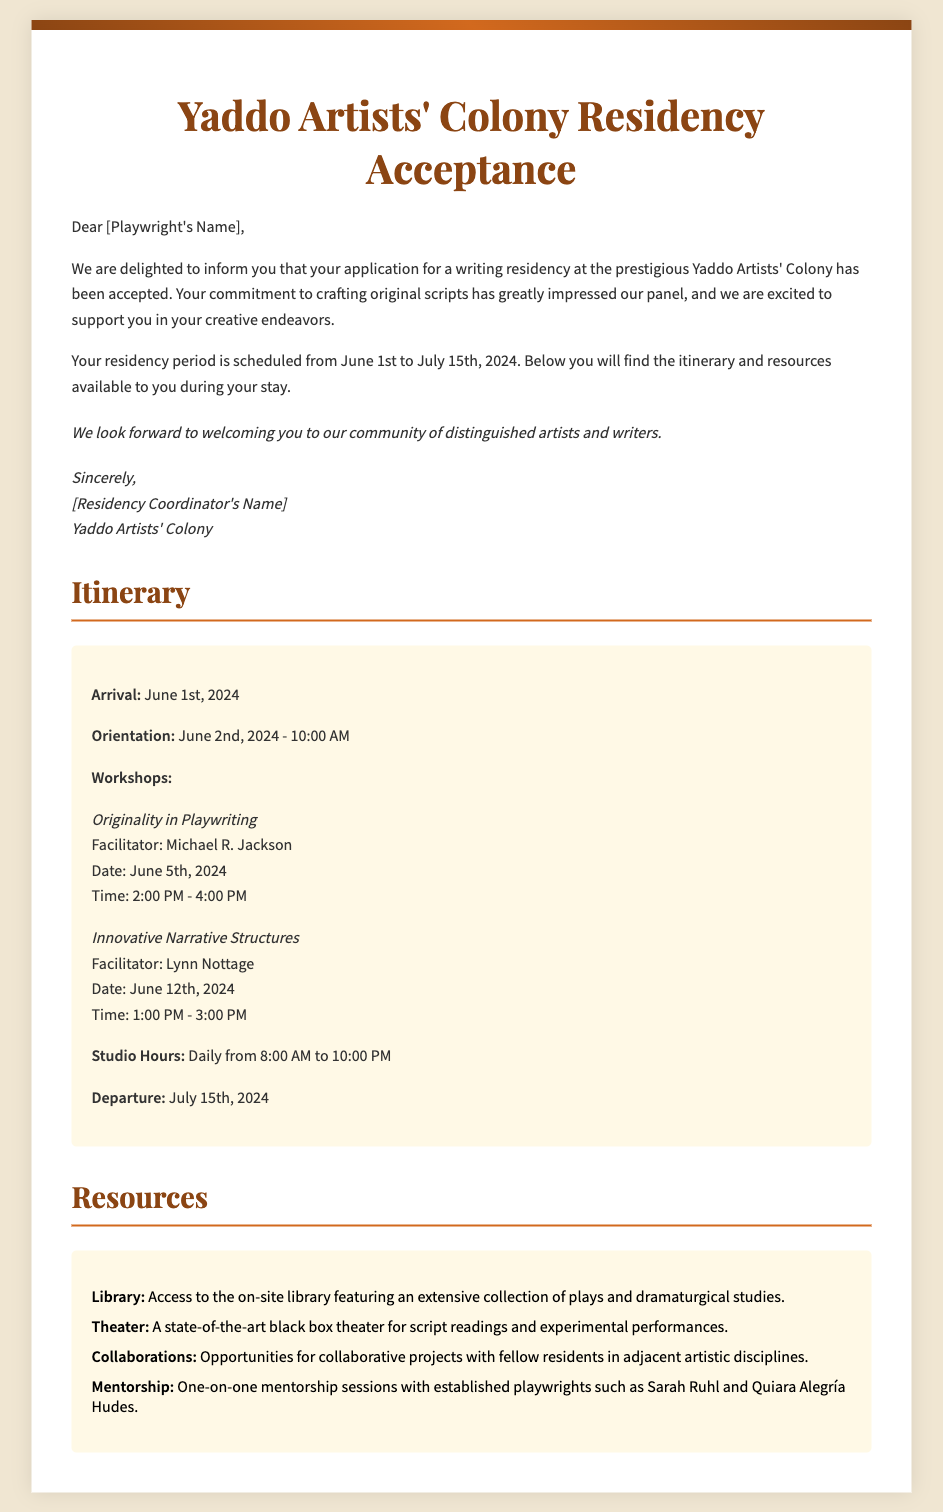What is the residency period? The residency period is specifically stated as "from June 1st to July 15th, 2024."
Answer: June 1st to July 15th, 2024 Who is the facilitator for the originality workshop? The name of the facilitator for the workshop on originality is mentioned in the document.
Answer: Michael R. Jackson What date is the orientation? The document specifies the exact date of the orientation event.
Answer: June 2nd, 2024 What time does the studio open? The document provides information about the daily opening hours of the studio.
Answer: 8:00 AM How many workshops are listed? The document includes the total number of workshop sessions presented in the itinerary.
Answer: Two What is one resource available to residents? The document lists various resources available during the residency, including details about access to the library.
Answer: Library What is the name of the theater mentioned? The document describes the project facility available to residents for performances.
Answer: Black box theater Who is the residency coordinator? The document contains the name of the individual coordinating the residency program.
Answer: [Residency Coordinator's Name] 